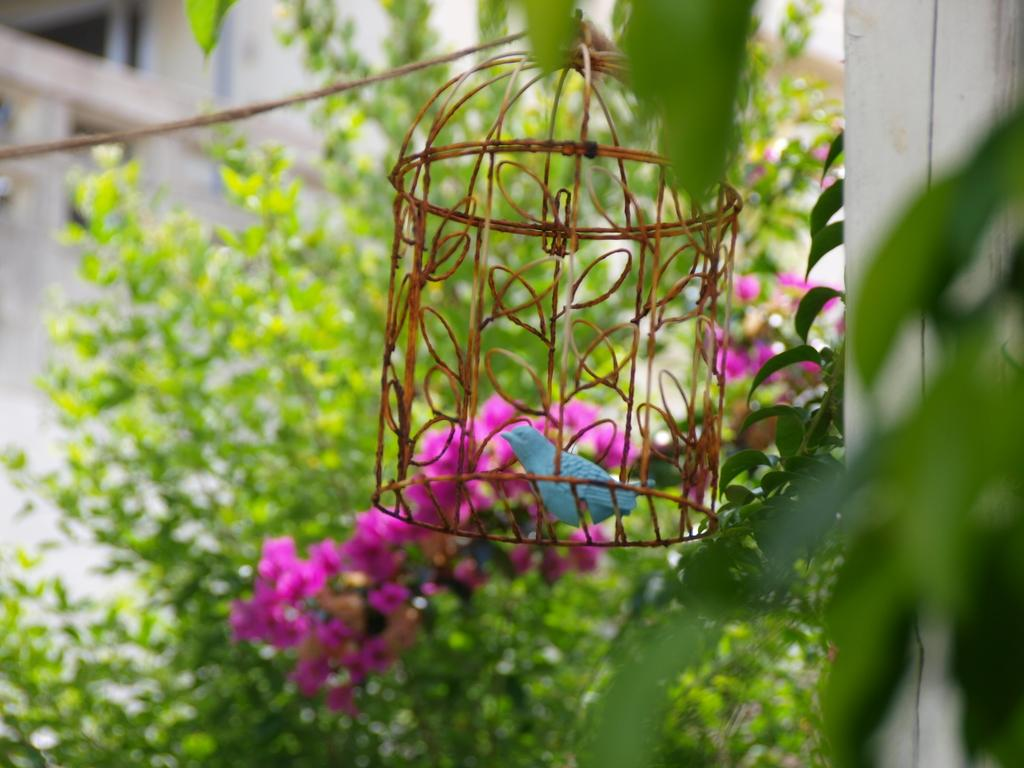What type of animal is in the cage in the image? There is a bird in a cage in the image. What other elements can be seen in the image besides the bird? There are flowers, a rope, leaves, and a wall in the background of the image. What type of work is the cat doing in the image? There is no cat present in the image, so it is not possible to answer that question. 